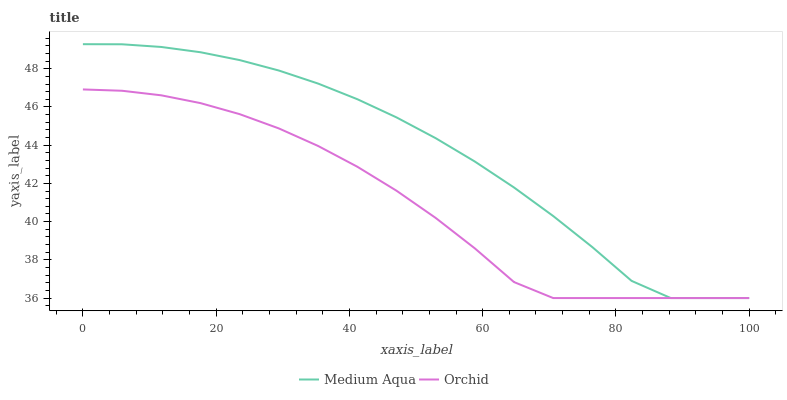Does Orchid have the minimum area under the curve?
Answer yes or no. Yes. Does Medium Aqua have the maximum area under the curve?
Answer yes or no. Yes. Does Orchid have the maximum area under the curve?
Answer yes or no. No. Is Orchid the smoothest?
Answer yes or no. Yes. Is Medium Aqua the roughest?
Answer yes or no. Yes. Is Orchid the roughest?
Answer yes or no. No. Does Medium Aqua have the lowest value?
Answer yes or no. Yes. Does Medium Aqua have the highest value?
Answer yes or no. Yes. Does Orchid have the highest value?
Answer yes or no. No. Does Orchid intersect Medium Aqua?
Answer yes or no. Yes. Is Orchid less than Medium Aqua?
Answer yes or no. No. Is Orchid greater than Medium Aqua?
Answer yes or no. No. 